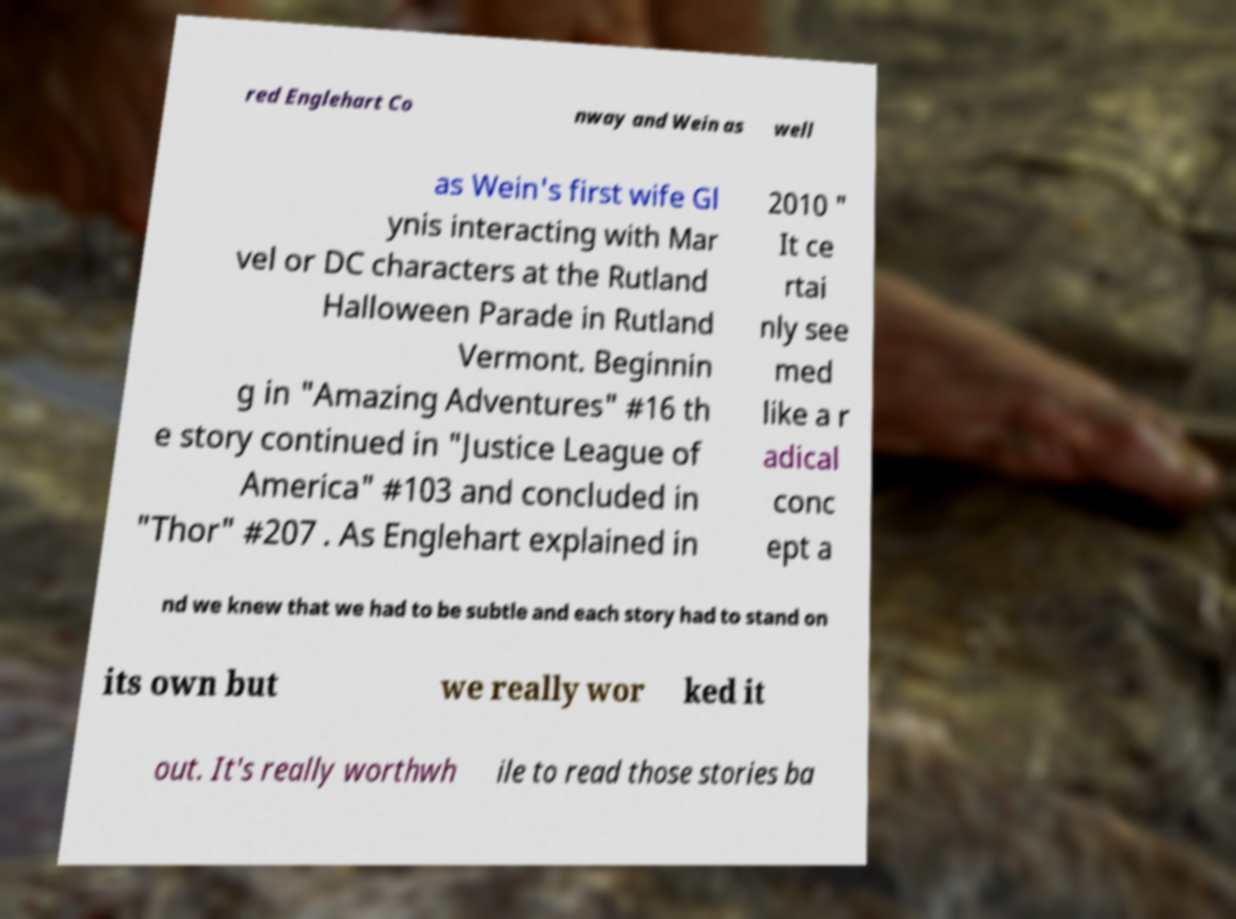Could you assist in decoding the text presented in this image and type it out clearly? red Englehart Co nway and Wein as well as Wein's first wife Gl ynis interacting with Mar vel or DC characters at the Rutland Halloween Parade in Rutland Vermont. Beginnin g in "Amazing Adventures" #16 th e story continued in "Justice League of America" #103 and concluded in "Thor" #207 . As Englehart explained in 2010 " It ce rtai nly see med like a r adical conc ept a nd we knew that we had to be subtle and each story had to stand on its own but we really wor ked it out. It's really worthwh ile to read those stories ba 